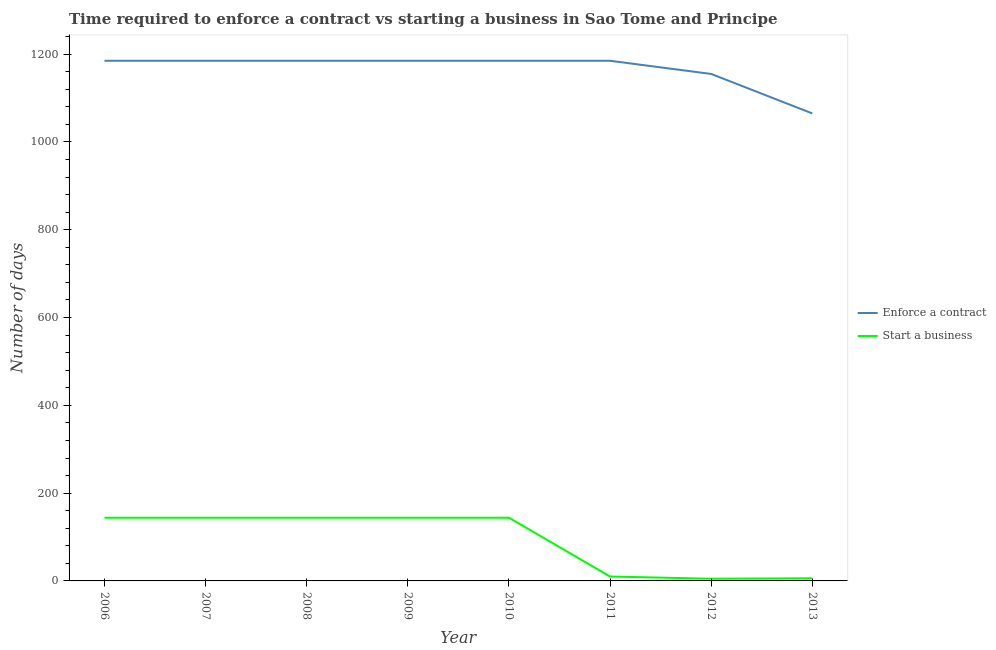What is the number of days to enforece a contract in 2006?
Make the answer very short. 1185. Across all years, what is the maximum number of days to enforece a contract?
Offer a terse response. 1185. Across all years, what is the minimum number of days to start a business?
Your response must be concise. 5. In which year was the number of days to enforece a contract minimum?
Keep it short and to the point. 2013. What is the total number of days to enforece a contract in the graph?
Offer a terse response. 9330. What is the difference between the number of days to enforece a contract in 2009 and that in 2013?
Your answer should be very brief. 120. What is the difference between the number of days to enforece a contract in 2013 and the number of days to start a business in 2008?
Give a very brief answer. 921. What is the average number of days to enforece a contract per year?
Your answer should be compact. 1166.25. In the year 2008, what is the difference between the number of days to enforece a contract and number of days to start a business?
Your answer should be compact. 1041. In how many years, is the number of days to enforece a contract greater than 200 days?
Your answer should be compact. 8. What is the ratio of the number of days to enforece a contract in 2007 to that in 2012?
Provide a short and direct response. 1.03. Is the number of days to start a business in 2007 less than that in 2012?
Give a very brief answer. No. Is the difference between the number of days to enforece a contract in 2007 and 2009 greater than the difference between the number of days to start a business in 2007 and 2009?
Provide a succinct answer. No. What is the difference between the highest and the lowest number of days to start a business?
Offer a terse response. 139. In how many years, is the number of days to start a business greater than the average number of days to start a business taken over all years?
Provide a short and direct response. 5. Is the sum of the number of days to enforece a contract in 2006 and 2012 greater than the maximum number of days to start a business across all years?
Your answer should be very brief. Yes. Does the number of days to enforece a contract monotonically increase over the years?
Make the answer very short. No. Is the number of days to enforece a contract strictly greater than the number of days to start a business over the years?
Make the answer very short. Yes. How many years are there in the graph?
Make the answer very short. 8. What is the difference between two consecutive major ticks on the Y-axis?
Make the answer very short. 200. Does the graph contain any zero values?
Your response must be concise. No. Does the graph contain grids?
Provide a succinct answer. No. What is the title of the graph?
Offer a very short reply. Time required to enforce a contract vs starting a business in Sao Tome and Principe. What is the label or title of the X-axis?
Your response must be concise. Year. What is the label or title of the Y-axis?
Provide a short and direct response. Number of days. What is the Number of days in Enforce a contract in 2006?
Provide a short and direct response. 1185. What is the Number of days in Start a business in 2006?
Make the answer very short. 144. What is the Number of days of Enforce a contract in 2007?
Your answer should be compact. 1185. What is the Number of days of Start a business in 2007?
Provide a short and direct response. 144. What is the Number of days in Enforce a contract in 2008?
Your response must be concise. 1185. What is the Number of days of Start a business in 2008?
Keep it short and to the point. 144. What is the Number of days of Enforce a contract in 2009?
Provide a short and direct response. 1185. What is the Number of days in Start a business in 2009?
Give a very brief answer. 144. What is the Number of days in Enforce a contract in 2010?
Your answer should be very brief. 1185. What is the Number of days of Start a business in 2010?
Your response must be concise. 144. What is the Number of days in Enforce a contract in 2011?
Keep it short and to the point. 1185. What is the Number of days in Enforce a contract in 2012?
Keep it short and to the point. 1155. What is the Number of days in Start a business in 2012?
Provide a succinct answer. 5. What is the Number of days in Enforce a contract in 2013?
Your response must be concise. 1065. What is the Number of days in Start a business in 2013?
Offer a terse response. 6. Across all years, what is the maximum Number of days of Enforce a contract?
Ensure brevity in your answer.  1185. Across all years, what is the maximum Number of days in Start a business?
Give a very brief answer. 144. Across all years, what is the minimum Number of days in Enforce a contract?
Give a very brief answer. 1065. What is the total Number of days in Enforce a contract in the graph?
Provide a succinct answer. 9330. What is the total Number of days in Start a business in the graph?
Offer a very short reply. 741. What is the difference between the Number of days in Enforce a contract in 2006 and that in 2007?
Give a very brief answer. 0. What is the difference between the Number of days of Start a business in 2006 and that in 2007?
Provide a succinct answer. 0. What is the difference between the Number of days in Start a business in 2006 and that in 2008?
Keep it short and to the point. 0. What is the difference between the Number of days of Start a business in 2006 and that in 2009?
Your answer should be very brief. 0. What is the difference between the Number of days of Enforce a contract in 2006 and that in 2010?
Provide a short and direct response. 0. What is the difference between the Number of days in Start a business in 2006 and that in 2011?
Provide a succinct answer. 134. What is the difference between the Number of days of Enforce a contract in 2006 and that in 2012?
Make the answer very short. 30. What is the difference between the Number of days of Start a business in 2006 and that in 2012?
Your answer should be very brief. 139. What is the difference between the Number of days of Enforce a contract in 2006 and that in 2013?
Provide a succinct answer. 120. What is the difference between the Number of days in Start a business in 2006 and that in 2013?
Provide a succinct answer. 138. What is the difference between the Number of days in Enforce a contract in 2007 and that in 2008?
Offer a terse response. 0. What is the difference between the Number of days in Start a business in 2007 and that in 2008?
Your answer should be very brief. 0. What is the difference between the Number of days of Enforce a contract in 2007 and that in 2009?
Offer a very short reply. 0. What is the difference between the Number of days in Start a business in 2007 and that in 2009?
Provide a succinct answer. 0. What is the difference between the Number of days of Enforce a contract in 2007 and that in 2010?
Your response must be concise. 0. What is the difference between the Number of days in Start a business in 2007 and that in 2010?
Make the answer very short. 0. What is the difference between the Number of days in Start a business in 2007 and that in 2011?
Ensure brevity in your answer.  134. What is the difference between the Number of days of Start a business in 2007 and that in 2012?
Your response must be concise. 139. What is the difference between the Number of days of Enforce a contract in 2007 and that in 2013?
Make the answer very short. 120. What is the difference between the Number of days of Start a business in 2007 and that in 2013?
Give a very brief answer. 138. What is the difference between the Number of days in Enforce a contract in 2008 and that in 2009?
Keep it short and to the point. 0. What is the difference between the Number of days of Start a business in 2008 and that in 2010?
Offer a terse response. 0. What is the difference between the Number of days of Enforce a contract in 2008 and that in 2011?
Offer a very short reply. 0. What is the difference between the Number of days in Start a business in 2008 and that in 2011?
Your response must be concise. 134. What is the difference between the Number of days in Start a business in 2008 and that in 2012?
Make the answer very short. 139. What is the difference between the Number of days in Enforce a contract in 2008 and that in 2013?
Keep it short and to the point. 120. What is the difference between the Number of days of Start a business in 2008 and that in 2013?
Give a very brief answer. 138. What is the difference between the Number of days of Enforce a contract in 2009 and that in 2010?
Your response must be concise. 0. What is the difference between the Number of days of Enforce a contract in 2009 and that in 2011?
Your answer should be compact. 0. What is the difference between the Number of days of Start a business in 2009 and that in 2011?
Keep it short and to the point. 134. What is the difference between the Number of days in Start a business in 2009 and that in 2012?
Provide a succinct answer. 139. What is the difference between the Number of days of Enforce a contract in 2009 and that in 2013?
Give a very brief answer. 120. What is the difference between the Number of days of Start a business in 2009 and that in 2013?
Offer a very short reply. 138. What is the difference between the Number of days of Enforce a contract in 2010 and that in 2011?
Provide a short and direct response. 0. What is the difference between the Number of days of Start a business in 2010 and that in 2011?
Your answer should be compact. 134. What is the difference between the Number of days of Enforce a contract in 2010 and that in 2012?
Your answer should be compact. 30. What is the difference between the Number of days of Start a business in 2010 and that in 2012?
Make the answer very short. 139. What is the difference between the Number of days in Enforce a contract in 2010 and that in 2013?
Offer a terse response. 120. What is the difference between the Number of days of Start a business in 2010 and that in 2013?
Your answer should be compact. 138. What is the difference between the Number of days of Enforce a contract in 2011 and that in 2012?
Make the answer very short. 30. What is the difference between the Number of days of Enforce a contract in 2011 and that in 2013?
Offer a very short reply. 120. What is the difference between the Number of days of Start a business in 2011 and that in 2013?
Your response must be concise. 4. What is the difference between the Number of days of Enforce a contract in 2006 and the Number of days of Start a business in 2007?
Make the answer very short. 1041. What is the difference between the Number of days of Enforce a contract in 2006 and the Number of days of Start a business in 2008?
Provide a succinct answer. 1041. What is the difference between the Number of days of Enforce a contract in 2006 and the Number of days of Start a business in 2009?
Your answer should be very brief. 1041. What is the difference between the Number of days of Enforce a contract in 2006 and the Number of days of Start a business in 2010?
Give a very brief answer. 1041. What is the difference between the Number of days of Enforce a contract in 2006 and the Number of days of Start a business in 2011?
Your answer should be compact. 1175. What is the difference between the Number of days in Enforce a contract in 2006 and the Number of days in Start a business in 2012?
Provide a short and direct response. 1180. What is the difference between the Number of days in Enforce a contract in 2006 and the Number of days in Start a business in 2013?
Offer a terse response. 1179. What is the difference between the Number of days in Enforce a contract in 2007 and the Number of days in Start a business in 2008?
Offer a terse response. 1041. What is the difference between the Number of days in Enforce a contract in 2007 and the Number of days in Start a business in 2009?
Provide a succinct answer. 1041. What is the difference between the Number of days of Enforce a contract in 2007 and the Number of days of Start a business in 2010?
Provide a short and direct response. 1041. What is the difference between the Number of days of Enforce a contract in 2007 and the Number of days of Start a business in 2011?
Keep it short and to the point. 1175. What is the difference between the Number of days of Enforce a contract in 2007 and the Number of days of Start a business in 2012?
Your response must be concise. 1180. What is the difference between the Number of days in Enforce a contract in 2007 and the Number of days in Start a business in 2013?
Provide a succinct answer. 1179. What is the difference between the Number of days of Enforce a contract in 2008 and the Number of days of Start a business in 2009?
Make the answer very short. 1041. What is the difference between the Number of days of Enforce a contract in 2008 and the Number of days of Start a business in 2010?
Offer a terse response. 1041. What is the difference between the Number of days of Enforce a contract in 2008 and the Number of days of Start a business in 2011?
Make the answer very short. 1175. What is the difference between the Number of days in Enforce a contract in 2008 and the Number of days in Start a business in 2012?
Give a very brief answer. 1180. What is the difference between the Number of days in Enforce a contract in 2008 and the Number of days in Start a business in 2013?
Offer a terse response. 1179. What is the difference between the Number of days in Enforce a contract in 2009 and the Number of days in Start a business in 2010?
Offer a terse response. 1041. What is the difference between the Number of days of Enforce a contract in 2009 and the Number of days of Start a business in 2011?
Keep it short and to the point. 1175. What is the difference between the Number of days in Enforce a contract in 2009 and the Number of days in Start a business in 2012?
Your response must be concise. 1180. What is the difference between the Number of days in Enforce a contract in 2009 and the Number of days in Start a business in 2013?
Provide a short and direct response. 1179. What is the difference between the Number of days in Enforce a contract in 2010 and the Number of days in Start a business in 2011?
Your response must be concise. 1175. What is the difference between the Number of days of Enforce a contract in 2010 and the Number of days of Start a business in 2012?
Keep it short and to the point. 1180. What is the difference between the Number of days in Enforce a contract in 2010 and the Number of days in Start a business in 2013?
Offer a terse response. 1179. What is the difference between the Number of days in Enforce a contract in 2011 and the Number of days in Start a business in 2012?
Keep it short and to the point. 1180. What is the difference between the Number of days in Enforce a contract in 2011 and the Number of days in Start a business in 2013?
Offer a very short reply. 1179. What is the difference between the Number of days of Enforce a contract in 2012 and the Number of days of Start a business in 2013?
Offer a terse response. 1149. What is the average Number of days in Enforce a contract per year?
Provide a succinct answer. 1166.25. What is the average Number of days in Start a business per year?
Provide a short and direct response. 92.62. In the year 2006, what is the difference between the Number of days of Enforce a contract and Number of days of Start a business?
Offer a very short reply. 1041. In the year 2007, what is the difference between the Number of days in Enforce a contract and Number of days in Start a business?
Offer a very short reply. 1041. In the year 2008, what is the difference between the Number of days of Enforce a contract and Number of days of Start a business?
Your answer should be very brief. 1041. In the year 2009, what is the difference between the Number of days of Enforce a contract and Number of days of Start a business?
Your answer should be very brief. 1041. In the year 2010, what is the difference between the Number of days of Enforce a contract and Number of days of Start a business?
Provide a succinct answer. 1041. In the year 2011, what is the difference between the Number of days in Enforce a contract and Number of days in Start a business?
Provide a succinct answer. 1175. In the year 2012, what is the difference between the Number of days in Enforce a contract and Number of days in Start a business?
Offer a terse response. 1150. In the year 2013, what is the difference between the Number of days of Enforce a contract and Number of days of Start a business?
Ensure brevity in your answer.  1059. What is the ratio of the Number of days in Start a business in 2006 to that in 2007?
Make the answer very short. 1. What is the ratio of the Number of days of Enforce a contract in 2006 to that in 2011?
Offer a very short reply. 1. What is the ratio of the Number of days in Enforce a contract in 2006 to that in 2012?
Provide a succinct answer. 1.03. What is the ratio of the Number of days of Start a business in 2006 to that in 2012?
Offer a terse response. 28.8. What is the ratio of the Number of days in Enforce a contract in 2006 to that in 2013?
Provide a succinct answer. 1.11. What is the ratio of the Number of days of Start a business in 2006 to that in 2013?
Provide a short and direct response. 24. What is the ratio of the Number of days of Enforce a contract in 2007 to that in 2008?
Keep it short and to the point. 1. What is the ratio of the Number of days in Start a business in 2007 to that in 2008?
Your answer should be compact. 1. What is the ratio of the Number of days in Start a business in 2007 to that in 2009?
Ensure brevity in your answer.  1. What is the ratio of the Number of days of Start a business in 2007 to that in 2011?
Your answer should be very brief. 14.4. What is the ratio of the Number of days of Start a business in 2007 to that in 2012?
Make the answer very short. 28.8. What is the ratio of the Number of days of Enforce a contract in 2007 to that in 2013?
Ensure brevity in your answer.  1.11. What is the ratio of the Number of days of Start a business in 2007 to that in 2013?
Your answer should be very brief. 24. What is the ratio of the Number of days in Enforce a contract in 2008 to that in 2012?
Ensure brevity in your answer.  1.03. What is the ratio of the Number of days of Start a business in 2008 to that in 2012?
Make the answer very short. 28.8. What is the ratio of the Number of days of Enforce a contract in 2008 to that in 2013?
Provide a succinct answer. 1.11. What is the ratio of the Number of days in Start a business in 2008 to that in 2013?
Your answer should be compact. 24. What is the ratio of the Number of days in Enforce a contract in 2009 to that in 2011?
Ensure brevity in your answer.  1. What is the ratio of the Number of days of Enforce a contract in 2009 to that in 2012?
Make the answer very short. 1.03. What is the ratio of the Number of days in Start a business in 2009 to that in 2012?
Make the answer very short. 28.8. What is the ratio of the Number of days in Enforce a contract in 2009 to that in 2013?
Make the answer very short. 1.11. What is the ratio of the Number of days of Enforce a contract in 2010 to that in 2011?
Give a very brief answer. 1. What is the ratio of the Number of days of Start a business in 2010 to that in 2011?
Provide a succinct answer. 14.4. What is the ratio of the Number of days of Enforce a contract in 2010 to that in 2012?
Your answer should be compact. 1.03. What is the ratio of the Number of days of Start a business in 2010 to that in 2012?
Your answer should be very brief. 28.8. What is the ratio of the Number of days in Enforce a contract in 2010 to that in 2013?
Your answer should be very brief. 1.11. What is the ratio of the Number of days of Start a business in 2010 to that in 2013?
Make the answer very short. 24. What is the ratio of the Number of days of Enforce a contract in 2011 to that in 2013?
Keep it short and to the point. 1.11. What is the ratio of the Number of days in Enforce a contract in 2012 to that in 2013?
Provide a short and direct response. 1.08. What is the difference between the highest and the lowest Number of days of Enforce a contract?
Offer a very short reply. 120. What is the difference between the highest and the lowest Number of days of Start a business?
Offer a very short reply. 139. 